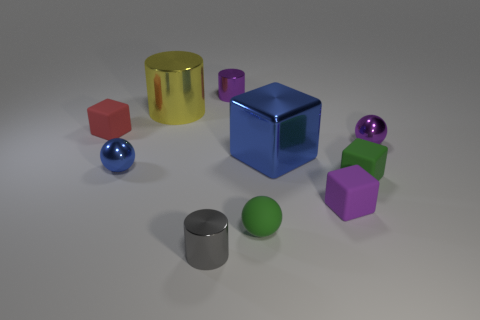Subtract all metallic balls. How many balls are left? 1 Subtract all red cubes. How many cubes are left? 3 Subtract all cyan cubes. Subtract all yellow cylinders. How many cubes are left? 4 Subtract all cubes. How many objects are left? 6 Add 1 shiny cylinders. How many shiny cylinders exist? 4 Subtract 0 brown cylinders. How many objects are left? 10 Subtract all green things. Subtract all red things. How many objects are left? 7 Add 6 large metal blocks. How many large metal blocks are left? 7 